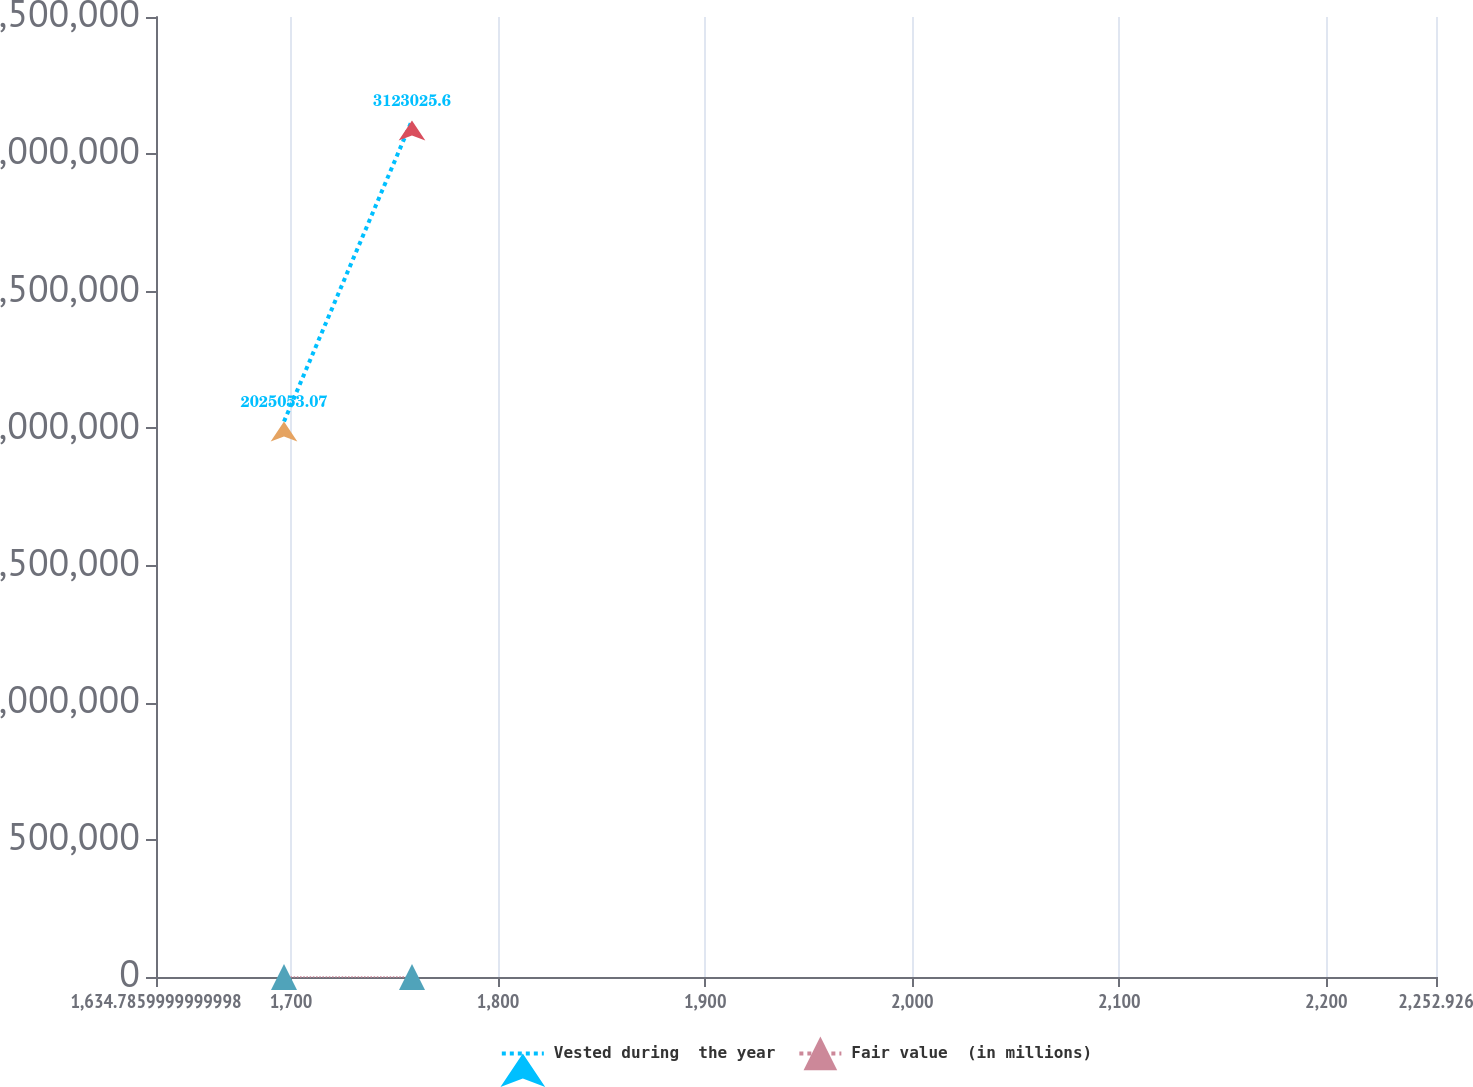Convert chart to OTSL. <chart><loc_0><loc_0><loc_500><loc_500><line_chart><ecel><fcel>Vested during  the year<fcel>Fair value  (in millions)<nl><fcel>1696.6<fcel>2.02505e+06<fcel>86.68<nl><fcel>1758.41<fcel>3.12303e+06<fcel>104.61<nl><fcel>2314.74<fcel>3.01765e+06<fcel>98.7<nl></chart> 